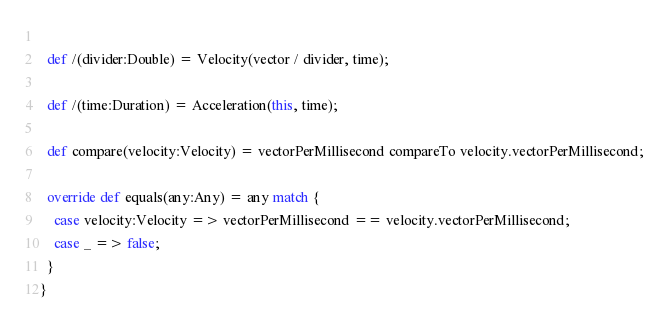<code> <loc_0><loc_0><loc_500><loc_500><_Scala_>  
  def /(divider:Double) = Velocity(vector / divider, time);
  
  def /(time:Duration) = Acceleration(this, time);
  
  def compare(velocity:Velocity) = vectorPerMillisecond compareTo velocity.vectorPerMillisecond;
  
  override def equals(any:Any) = any match {
    case velocity:Velocity => vectorPerMillisecond == velocity.vectorPerMillisecond;
    case _ => false;
  }
}</code> 